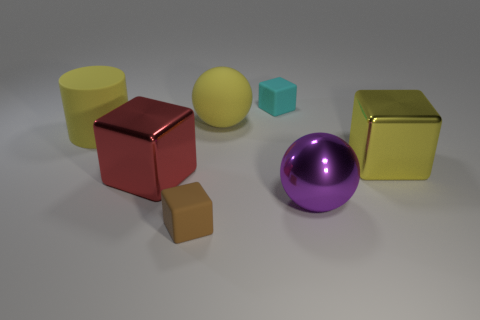Add 2 large gray metal cylinders. How many objects exist? 9 Subtract all balls. How many objects are left? 5 Add 5 large yellow cubes. How many large yellow cubes are left? 6 Add 1 cyan matte objects. How many cyan matte objects exist? 2 Subtract 0 green cylinders. How many objects are left? 7 Subtract all cyan matte objects. Subtract all yellow spheres. How many objects are left? 5 